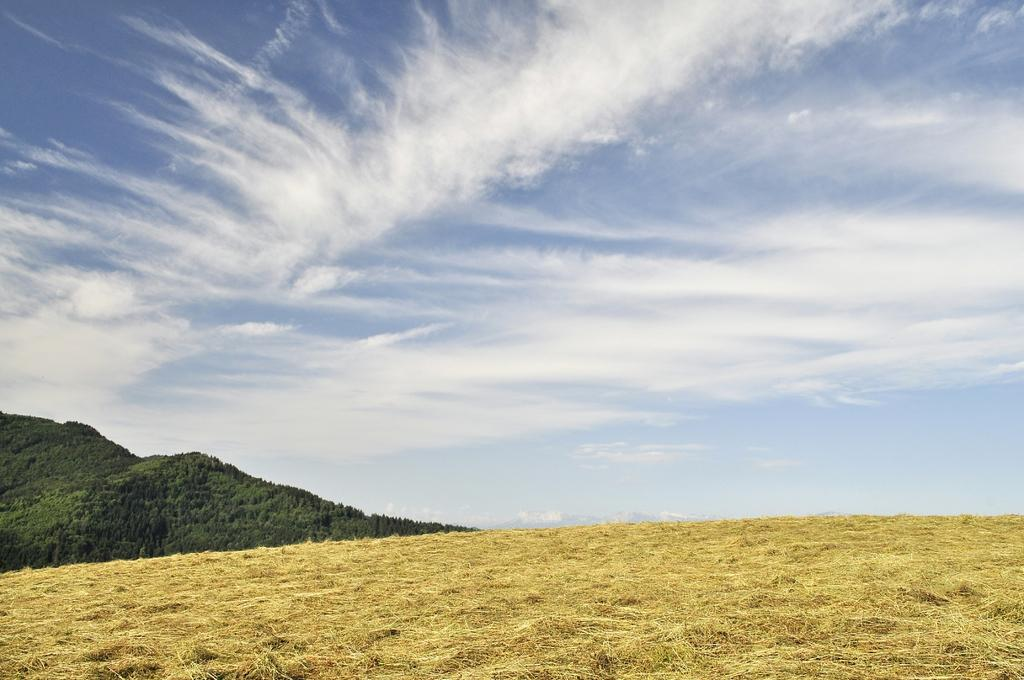What type of vegetation can be seen in the image? There are trees in the image. What is the color of the trees? The trees are green. What other type of vegetation is present in the image? There is grass in the image. What is the color of the grass? The grass is brown. What else can be seen in the sky in the image? The sky is visible in the image, and it is blue and white. What type of advertisement can be seen on the trees in the image? There are no advertisements present on the trees in the image. What is the wealth status of the person who owns the grass in the image? There is no information about the wealth status of the person who owns the grass in the image. 